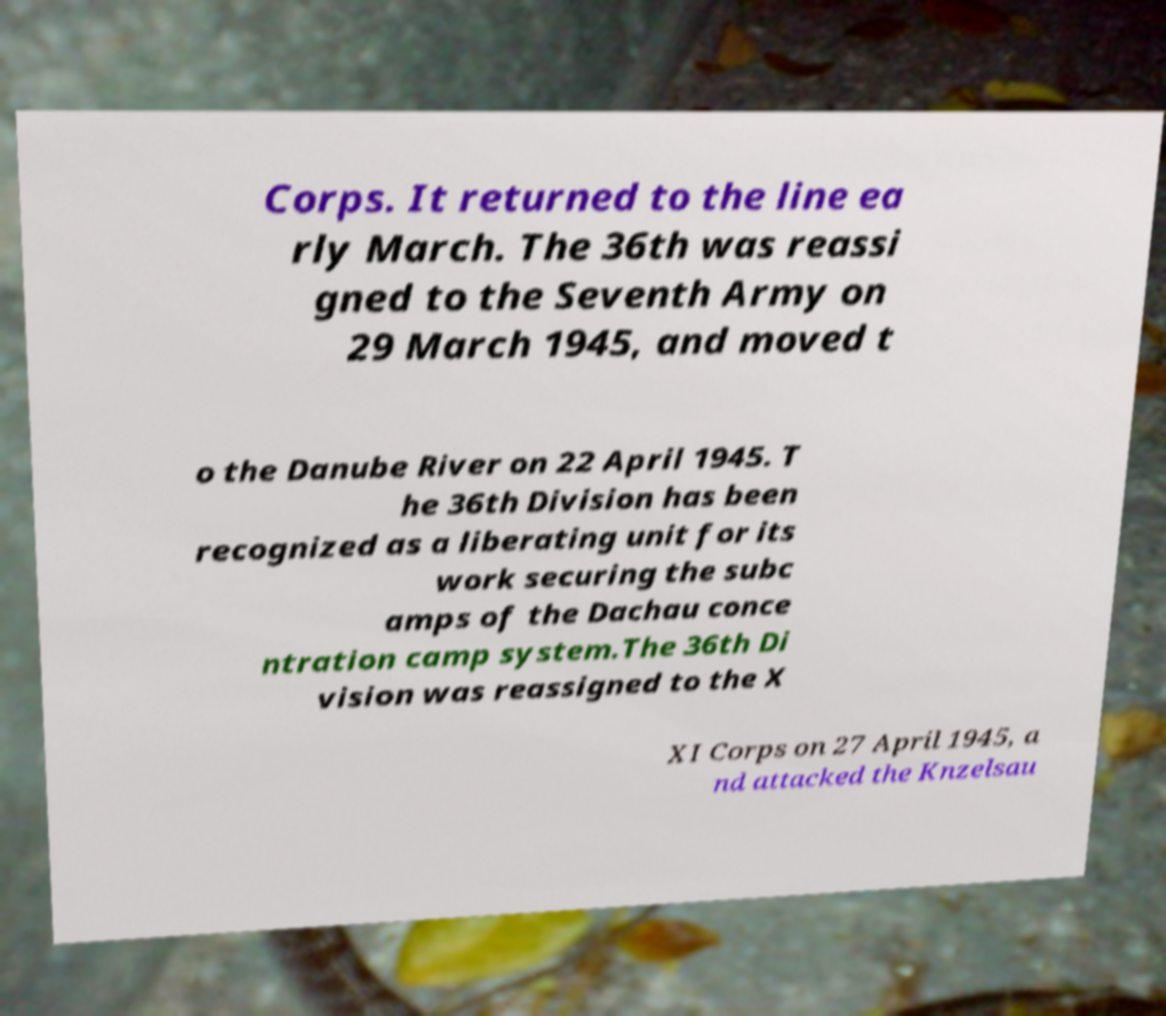For documentation purposes, I need the text within this image transcribed. Could you provide that? Corps. It returned to the line ea rly March. The 36th was reassi gned to the Seventh Army on 29 March 1945, and moved t o the Danube River on 22 April 1945. T he 36th Division has been recognized as a liberating unit for its work securing the subc amps of the Dachau conce ntration camp system.The 36th Di vision was reassigned to the X XI Corps on 27 April 1945, a nd attacked the Knzelsau 